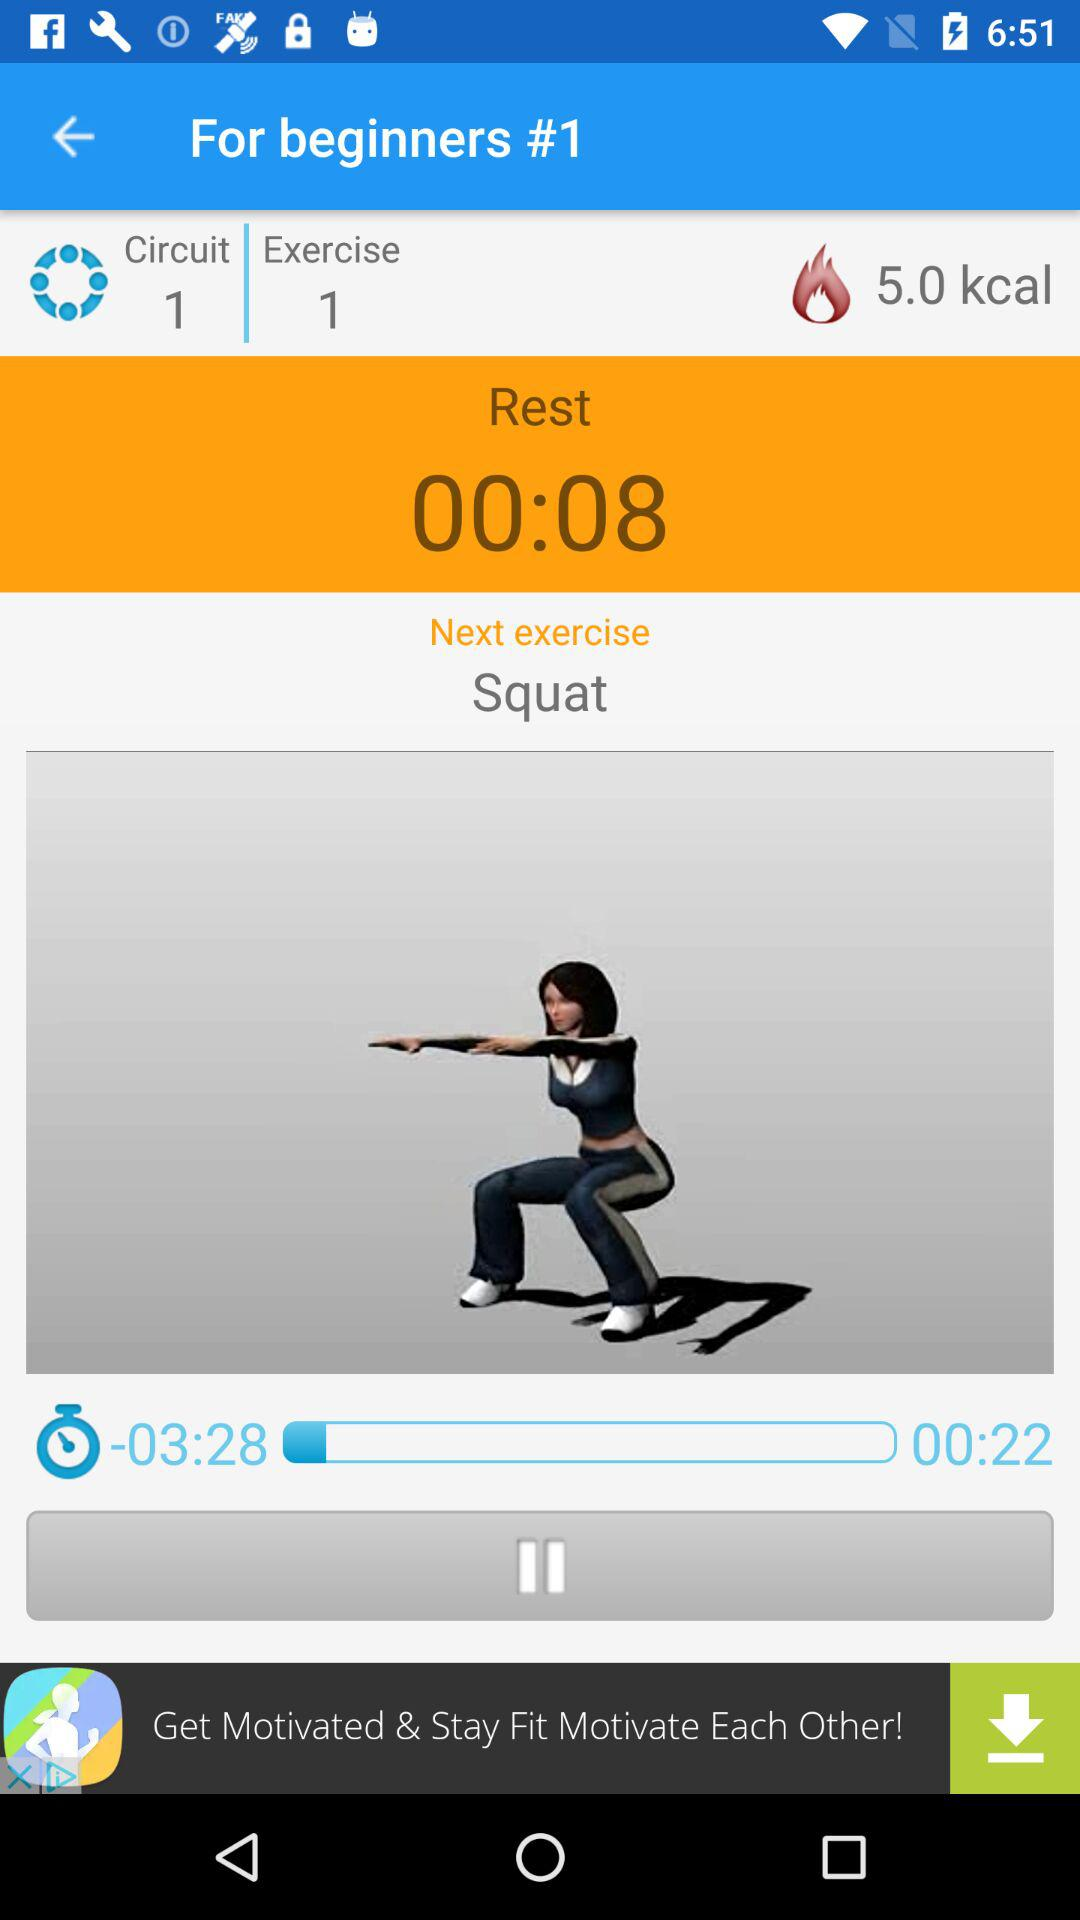What is the exercise number? The exercise number is 1. 